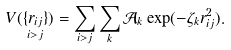Convert formula to latex. <formula><loc_0><loc_0><loc_500><loc_500>V ( \underset { i > j } { \{ r _ { i j } \} } ) = \sum _ { i > j } \sum _ { k } \mathcal { A } _ { k } \exp ( - \zeta _ { k } r _ { i j } ^ { 2 } ) .</formula> 